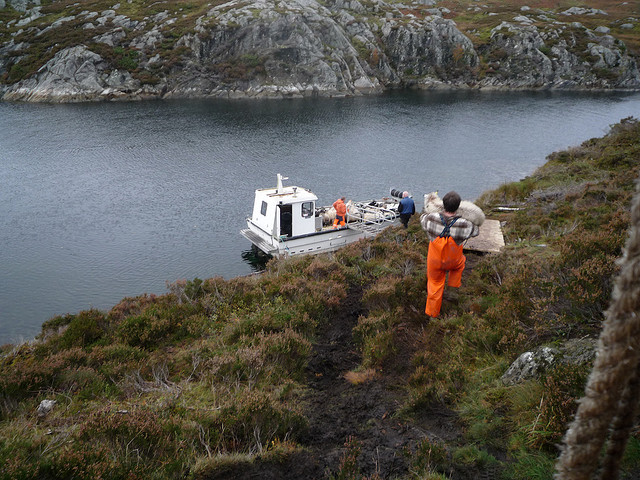<image>What country are they in? I am not sure what country they are in. It can be Canada, England, Iceland, Russia, Sweden or USA. What country are they in? I don't know what country they are in. It could be Canada, England, Iceland, Russia, Sweden, USA, or America. 